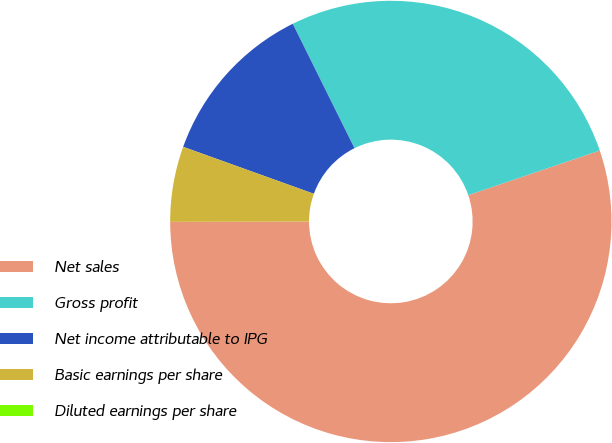Convert chart to OTSL. <chart><loc_0><loc_0><loc_500><loc_500><pie_chart><fcel>Net sales<fcel>Gross profit<fcel>Net income attributable to IPG<fcel>Basic earnings per share<fcel>Diluted earnings per share<nl><fcel>55.18%<fcel>27.12%<fcel>12.18%<fcel>5.52%<fcel>0.0%<nl></chart> 